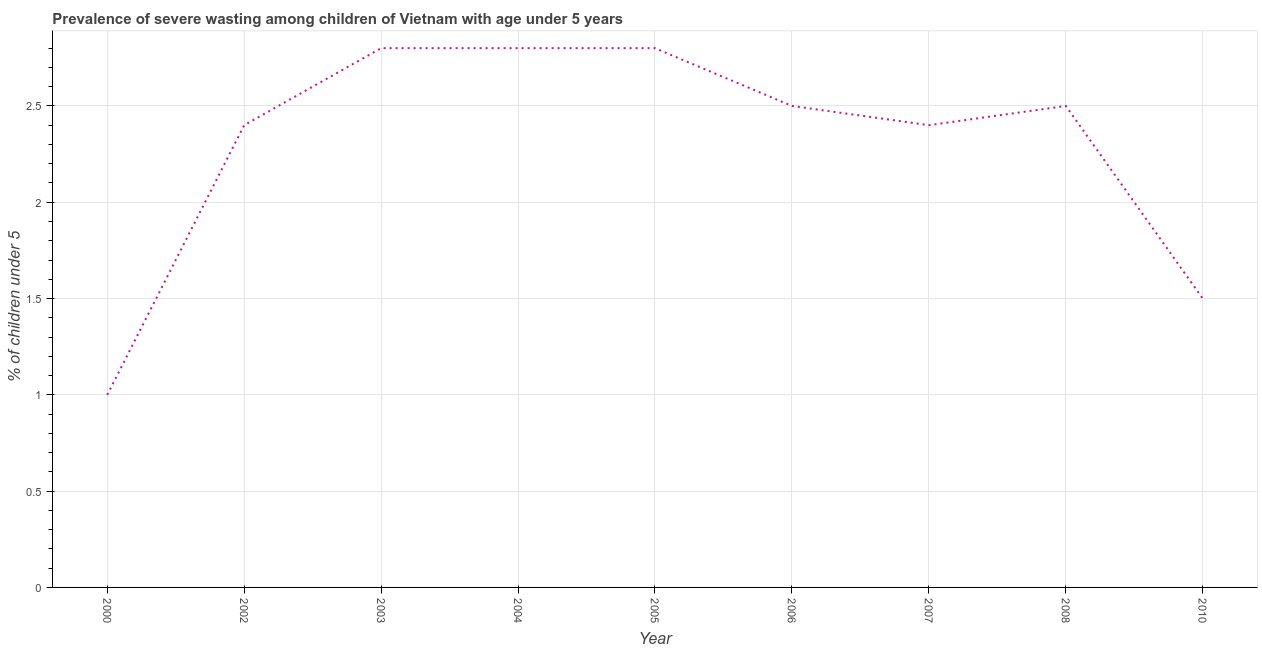Across all years, what is the maximum prevalence of severe wasting?
Provide a short and direct response. 2.8. Across all years, what is the minimum prevalence of severe wasting?
Offer a very short reply. 1. In which year was the prevalence of severe wasting minimum?
Keep it short and to the point. 2000. What is the sum of the prevalence of severe wasting?
Give a very brief answer. 20.7. What is the difference between the prevalence of severe wasting in 2004 and 2010?
Make the answer very short. 1.3. What is the average prevalence of severe wasting per year?
Your answer should be compact. 2.3. What is the ratio of the prevalence of severe wasting in 2003 to that in 2010?
Your response must be concise. 1.87. Is the difference between the prevalence of severe wasting in 2002 and 2005 greater than the difference between any two years?
Ensure brevity in your answer.  No. What is the difference between the highest and the second highest prevalence of severe wasting?
Ensure brevity in your answer.  0. Is the sum of the prevalence of severe wasting in 2003 and 2007 greater than the maximum prevalence of severe wasting across all years?
Provide a succinct answer. Yes. What is the difference between the highest and the lowest prevalence of severe wasting?
Your answer should be very brief. 1.8. How many lines are there?
Your response must be concise. 1. What is the difference between two consecutive major ticks on the Y-axis?
Ensure brevity in your answer.  0.5. Are the values on the major ticks of Y-axis written in scientific E-notation?
Your response must be concise. No. What is the title of the graph?
Give a very brief answer. Prevalence of severe wasting among children of Vietnam with age under 5 years. What is the label or title of the Y-axis?
Your answer should be compact.  % of children under 5. What is the  % of children under 5 in 2000?
Ensure brevity in your answer.  1. What is the  % of children under 5 of 2002?
Ensure brevity in your answer.  2.4. What is the  % of children under 5 in 2003?
Your response must be concise. 2.8. What is the  % of children under 5 in 2004?
Ensure brevity in your answer.  2.8. What is the  % of children under 5 of 2005?
Your answer should be compact. 2.8. What is the  % of children under 5 of 2006?
Your answer should be very brief. 2.5. What is the  % of children under 5 in 2007?
Provide a succinct answer. 2.4. What is the difference between the  % of children under 5 in 2000 and 2004?
Give a very brief answer. -1.8. What is the difference between the  % of children under 5 in 2000 and 2005?
Provide a short and direct response. -1.8. What is the difference between the  % of children under 5 in 2000 and 2007?
Ensure brevity in your answer.  -1.4. What is the difference between the  % of children under 5 in 2000 and 2010?
Offer a terse response. -0.5. What is the difference between the  % of children under 5 in 2002 and 2003?
Keep it short and to the point. -0.4. What is the difference between the  % of children under 5 in 2002 and 2005?
Offer a terse response. -0.4. What is the difference between the  % of children under 5 in 2002 and 2006?
Keep it short and to the point. -0.1. What is the difference between the  % of children under 5 in 2002 and 2007?
Your answer should be very brief. 0. What is the difference between the  % of children under 5 in 2003 and 2007?
Give a very brief answer. 0.4. What is the difference between the  % of children under 5 in 2003 and 2008?
Make the answer very short. 0.3. What is the difference between the  % of children under 5 in 2004 and 2005?
Ensure brevity in your answer.  0. What is the difference between the  % of children under 5 in 2004 and 2006?
Offer a very short reply. 0.3. What is the difference between the  % of children under 5 in 2005 and 2006?
Offer a very short reply. 0.3. What is the difference between the  % of children under 5 in 2005 and 2010?
Provide a short and direct response. 1.3. What is the difference between the  % of children under 5 in 2006 and 2008?
Your answer should be very brief. 0. What is the difference between the  % of children under 5 in 2007 and 2010?
Provide a short and direct response. 0.9. What is the ratio of the  % of children under 5 in 2000 to that in 2002?
Your answer should be compact. 0.42. What is the ratio of the  % of children under 5 in 2000 to that in 2003?
Make the answer very short. 0.36. What is the ratio of the  % of children under 5 in 2000 to that in 2004?
Your response must be concise. 0.36. What is the ratio of the  % of children under 5 in 2000 to that in 2005?
Your response must be concise. 0.36. What is the ratio of the  % of children under 5 in 2000 to that in 2007?
Give a very brief answer. 0.42. What is the ratio of the  % of children under 5 in 2000 to that in 2010?
Keep it short and to the point. 0.67. What is the ratio of the  % of children under 5 in 2002 to that in 2003?
Your response must be concise. 0.86. What is the ratio of the  % of children under 5 in 2002 to that in 2004?
Offer a terse response. 0.86. What is the ratio of the  % of children under 5 in 2002 to that in 2005?
Keep it short and to the point. 0.86. What is the ratio of the  % of children under 5 in 2002 to that in 2008?
Give a very brief answer. 0.96. What is the ratio of the  % of children under 5 in 2002 to that in 2010?
Ensure brevity in your answer.  1.6. What is the ratio of the  % of children under 5 in 2003 to that in 2005?
Provide a short and direct response. 1. What is the ratio of the  % of children under 5 in 2003 to that in 2006?
Make the answer very short. 1.12. What is the ratio of the  % of children under 5 in 2003 to that in 2007?
Make the answer very short. 1.17. What is the ratio of the  % of children under 5 in 2003 to that in 2008?
Ensure brevity in your answer.  1.12. What is the ratio of the  % of children under 5 in 2003 to that in 2010?
Offer a terse response. 1.87. What is the ratio of the  % of children under 5 in 2004 to that in 2005?
Make the answer very short. 1. What is the ratio of the  % of children under 5 in 2004 to that in 2006?
Your answer should be very brief. 1.12. What is the ratio of the  % of children under 5 in 2004 to that in 2007?
Give a very brief answer. 1.17. What is the ratio of the  % of children under 5 in 2004 to that in 2008?
Your answer should be very brief. 1.12. What is the ratio of the  % of children under 5 in 2004 to that in 2010?
Provide a succinct answer. 1.87. What is the ratio of the  % of children under 5 in 2005 to that in 2006?
Your answer should be compact. 1.12. What is the ratio of the  % of children under 5 in 2005 to that in 2007?
Your response must be concise. 1.17. What is the ratio of the  % of children under 5 in 2005 to that in 2008?
Your response must be concise. 1.12. What is the ratio of the  % of children under 5 in 2005 to that in 2010?
Offer a terse response. 1.87. What is the ratio of the  % of children under 5 in 2006 to that in 2007?
Provide a succinct answer. 1.04. What is the ratio of the  % of children under 5 in 2006 to that in 2008?
Give a very brief answer. 1. What is the ratio of the  % of children under 5 in 2006 to that in 2010?
Your answer should be compact. 1.67. What is the ratio of the  % of children under 5 in 2007 to that in 2008?
Give a very brief answer. 0.96. What is the ratio of the  % of children under 5 in 2007 to that in 2010?
Make the answer very short. 1.6. What is the ratio of the  % of children under 5 in 2008 to that in 2010?
Provide a short and direct response. 1.67. 